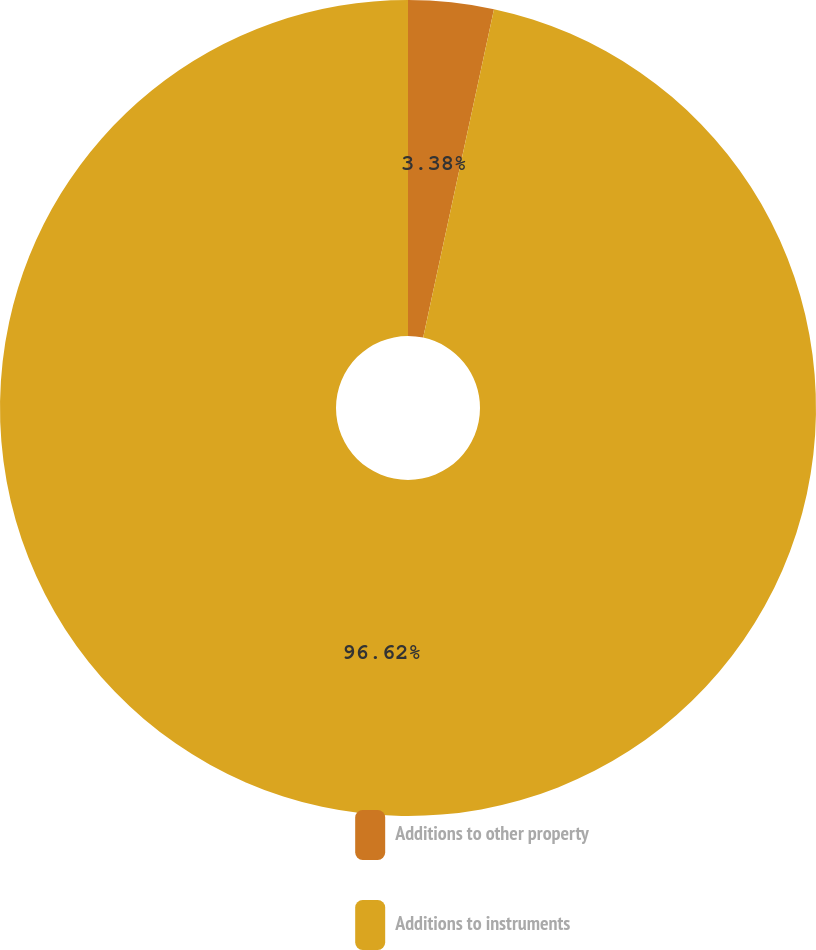<chart> <loc_0><loc_0><loc_500><loc_500><pie_chart><fcel>Additions to other property<fcel>Additions to instruments<nl><fcel>3.38%<fcel>96.62%<nl></chart> 